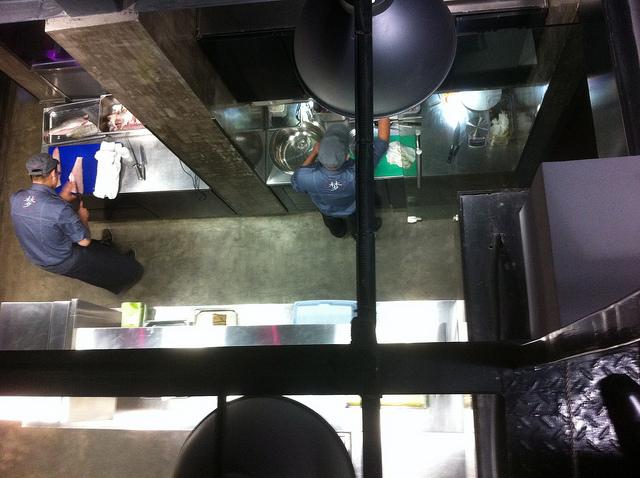Will these workers get in trouble if they mess around on the job?
Answer briefly. Yes. At what level was this photo taken?
Give a very brief answer. Above. Does the man have on a hat?
Give a very brief answer. Yes. 